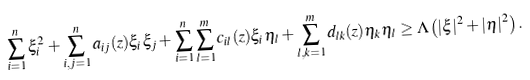Convert formula to latex. <formula><loc_0><loc_0><loc_500><loc_500>\sum _ { i = 1 } ^ { n } \xi _ { i } ^ { 2 } + \sum _ { i , j = 1 } ^ { n } a _ { i j } ( z ) \xi _ { i } \xi _ { j } + \sum _ { i = 1 } ^ { n } \sum _ { l = 1 } ^ { m } c _ { i l } ( z ) \xi _ { i } \eta _ { l } + \sum _ { l , k = 1 } ^ { m } d _ { l k } ( z ) \eta _ { k } \eta _ { l } \geq \Lambda \left ( | \xi | ^ { 2 } + | \eta | ^ { 2 } \right ) .</formula> 